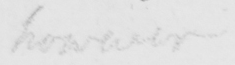What text is written in this handwritten line? however 